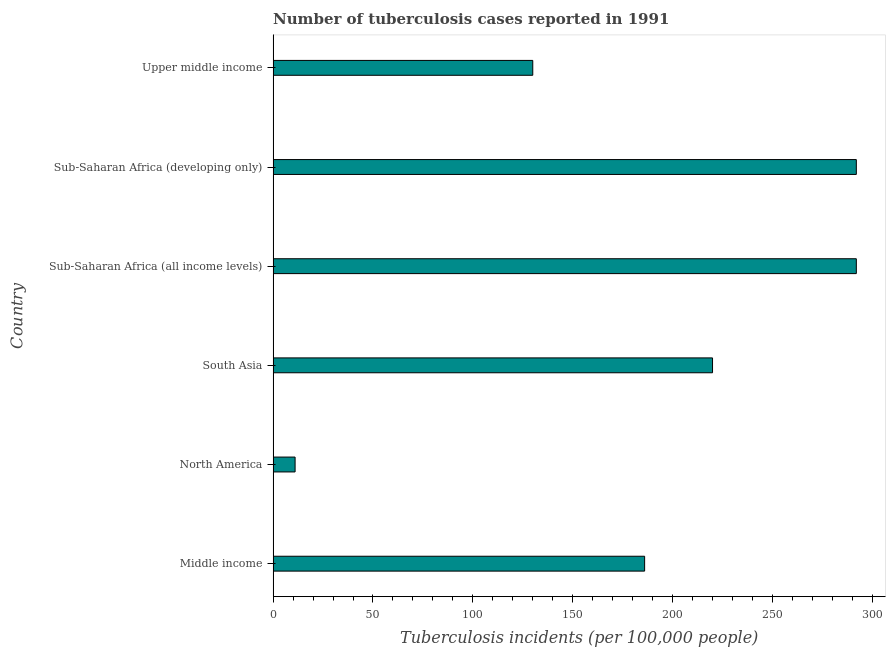Does the graph contain any zero values?
Your answer should be compact. No. What is the title of the graph?
Provide a short and direct response. Number of tuberculosis cases reported in 1991. What is the label or title of the X-axis?
Provide a succinct answer. Tuberculosis incidents (per 100,0 people). What is the label or title of the Y-axis?
Your response must be concise. Country. What is the number of tuberculosis incidents in North America?
Provide a succinct answer. 11. Across all countries, what is the maximum number of tuberculosis incidents?
Ensure brevity in your answer.  292. Across all countries, what is the minimum number of tuberculosis incidents?
Offer a very short reply. 11. In which country was the number of tuberculosis incidents maximum?
Provide a short and direct response. Sub-Saharan Africa (all income levels). What is the sum of the number of tuberculosis incidents?
Your response must be concise. 1131. What is the difference between the number of tuberculosis incidents in North America and Sub-Saharan Africa (developing only)?
Ensure brevity in your answer.  -281. What is the average number of tuberculosis incidents per country?
Offer a very short reply. 188.5. What is the median number of tuberculosis incidents?
Your response must be concise. 203. What is the ratio of the number of tuberculosis incidents in Middle income to that in Sub-Saharan Africa (developing only)?
Your answer should be compact. 0.64. Is the number of tuberculosis incidents in Sub-Saharan Africa (all income levels) less than that in Upper middle income?
Provide a short and direct response. No. What is the difference between the highest and the second highest number of tuberculosis incidents?
Offer a terse response. 0. Is the sum of the number of tuberculosis incidents in North America and South Asia greater than the maximum number of tuberculosis incidents across all countries?
Offer a very short reply. No. What is the difference between the highest and the lowest number of tuberculosis incidents?
Make the answer very short. 281. In how many countries, is the number of tuberculosis incidents greater than the average number of tuberculosis incidents taken over all countries?
Your response must be concise. 3. How many countries are there in the graph?
Keep it short and to the point. 6. What is the difference between two consecutive major ticks on the X-axis?
Your response must be concise. 50. Are the values on the major ticks of X-axis written in scientific E-notation?
Your answer should be very brief. No. What is the Tuberculosis incidents (per 100,000 people) of Middle income?
Your response must be concise. 186. What is the Tuberculosis incidents (per 100,000 people) of South Asia?
Provide a succinct answer. 220. What is the Tuberculosis incidents (per 100,000 people) of Sub-Saharan Africa (all income levels)?
Your response must be concise. 292. What is the Tuberculosis incidents (per 100,000 people) in Sub-Saharan Africa (developing only)?
Give a very brief answer. 292. What is the Tuberculosis incidents (per 100,000 people) in Upper middle income?
Provide a succinct answer. 130. What is the difference between the Tuberculosis incidents (per 100,000 people) in Middle income and North America?
Keep it short and to the point. 175. What is the difference between the Tuberculosis incidents (per 100,000 people) in Middle income and South Asia?
Your response must be concise. -34. What is the difference between the Tuberculosis incidents (per 100,000 people) in Middle income and Sub-Saharan Africa (all income levels)?
Offer a very short reply. -106. What is the difference between the Tuberculosis incidents (per 100,000 people) in Middle income and Sub-Saharan Africa (developing only)?
Ensure brevity in your answer.  -106. What is the difference between the Tuberculosis incidents (per 100,000 people) in Middle income and Upper middle income?
Your answer should be very brief. 56. What is the difference between the Tuberculosis incidents (per 100,000 people) in North America and South Asia?
Offer a terse response. -209. What is the difference between the Tuberculosis incidents (per 100,000 people) in North America and Sub-Saharan Africa (all income levels)?
Offer a terse response. -281. What is the difference between the Tuberculosis incidents (per 100,000 people) in North America and Sub-Saharan Africa (developing only)?
Ensure brevity in your answer.  -281. What is the difference between the Tuberculosis incidents (per 100,000 people) in North America and Upper middle income?
Keep it short and to the point. -119. What is the difference between the Tuberculosis incidents (per 100,000 people) in South Asia and Sub-Saharan Africa (all income levels)?
Your answer should be compact. -72. What is the difference between the Tuberculosis incidents (per 100,000 people) in South Asia and Sub-Saharan Africa (developing only)?
Provide a succinct answer. -72. What is the difference between the Tuberculosis incidents (per 100,000 people) in Sub-Saharan Africa (all income levels) and Upper middle income?
Keep it short and to the point. 162. What is the difference between the Tuberculosis incidents (per 100,000 people) in Sub-Saharan Africa (developing only) and Upper middle income?
Your response must be concise. 162. What is the ratio of the Tuberculosis incidents (per 100,000 people) in Middle income to that in North America?
Your response must be concise. 16.91. What is the ratio of the Tuberculosis incidents (per 100,000 people) in Middle income to that in South Asia?
Your response must be concise. 0.84. What is the ratio of the Tuberculosis incidents (per 100,000 people) in Middle income to that in Sub-Saharan Africa (all income levels)?
Offer a very short reply. 0.64. What is the ratio of the Tuberculosis incidents (per 100,000 people) in Middle income to that in Sub-Saharan Africa (developing only)?
Provide a short and direct response. 0.64. What is the ratio of the Tuberculosis incidents (per 100,000 people) in Middle income to that in Upper middle income?
Make the answer very short. 1.43. What is the ratio of the Tuberculosis incidents (per 100,000 people) in North America to that in Sub-Saharan Africa (all income levels)?
Offer a very short reply. 0.04. What is the ratio of the Tuberculosis incidents (per 100,000 people) in North America to that in Sub-Saharan Africa (developing only)?
Your response must be concise. 0.04. What is the ratio of the Tuberculosis incidents (per 100,000 people) in North America to that in Upper middle income?
Your answer should be compact. 0.09. What is the ratio of the Tuberculosis incidents (per 100,000 people) in South Asia to that in Sub-Saharan Africa (all income levels)?
Your answer should be compact. 0.75. What is the ratio of the Tuberculosis incidents (per 100,000 people) in South Asia to that in Sub-Saharan Africa (developing only)?
Make the answer very short. 0.75. What is the ratio of the Tuberculosis incidents (per 100,000 people) in South Asia to that in Upper middle income?
Your response must be concise. 1.69. What is the ratio of the Tuberculosis incidents (per 100,000 people) in Sub-Saharan Africa (all income levels) to that in Upper middle income?
Your answer should be compact. 2.25. What is the ratio of the Tuberculosis incidents (per 100,000 people) in Sub-Saharan Africa (developing only) to that in Upper middle income?
Offer a terse response. 2.25. 